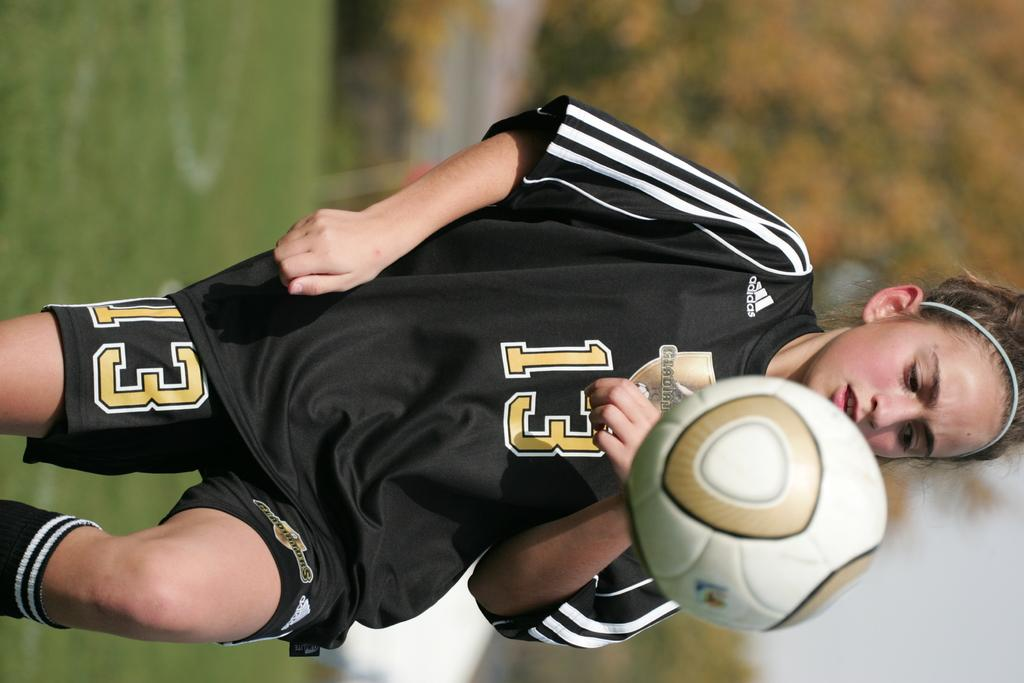Who is the main subject in the foreground of the picture? There is a girl in the foreground of the picture. What is the girl doing in the picture? The girl is on the ground. What is happening with the ball in the picture? The ball is in the air. What can be seen in the background of the picture? There is a tree, grass, and the sky visible in the background of the picture. Can you hear the bell ringing in the picture? There is no bell present in the image, so it cannot be heard ringing. 